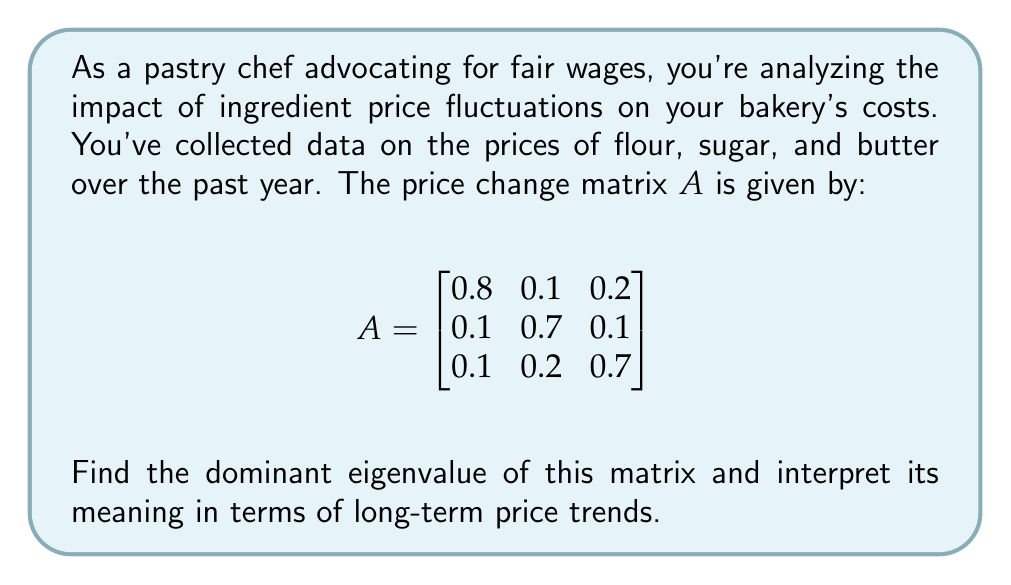Help me with this question. To find the dominant eigenvalue, we need to:

1. Find the characteristic equation:
   $det(A - \lambda I) = 0$
   
   $$\begin{vmatrix}
   0.8 - \lambda & 0.1 & 0.2 \\
   0.1 & 0.7 - \lambda & 0.1 \\
   0.1 & 0.2 & 0.7 - \lambda
   \end{vmatrix} = 0$$

2. Expand the determinant:
   $(0.8 - \lambda)[(0.7 - \lambda)^2 - 0.02] - 0.1[0.1(0.7 - \lambda) - 0.02] + 0.2[0.1(0.7 - \lambda) - 0.01] = 0$

3. Simplify:
   $-\lambda^3 + 2.2\lambda^2 - 1.51\lambda + 0.322 = 0$

4. Solve the cubic equation. The roots are approximately:
   $\lambda_1 \approx 1$
   $\lambda_2 \approx 0.6$
   $\lambda_3 \approx 0.6$

5. The dominant eigenvalue is the largest in magnitude: $\lambda_1 \approx 1$

Interpretation: The dominant eigenvalue being approximately 1 suggests that the overall price trend is relatively stable in the long term. This means that while there may be short-term fluctuations, the prices of flour, sugar, and butter are not expected to significantly increase or decrease over time.
Answer: $\lambda_1 \approx 1$, indicating long-term price stability 